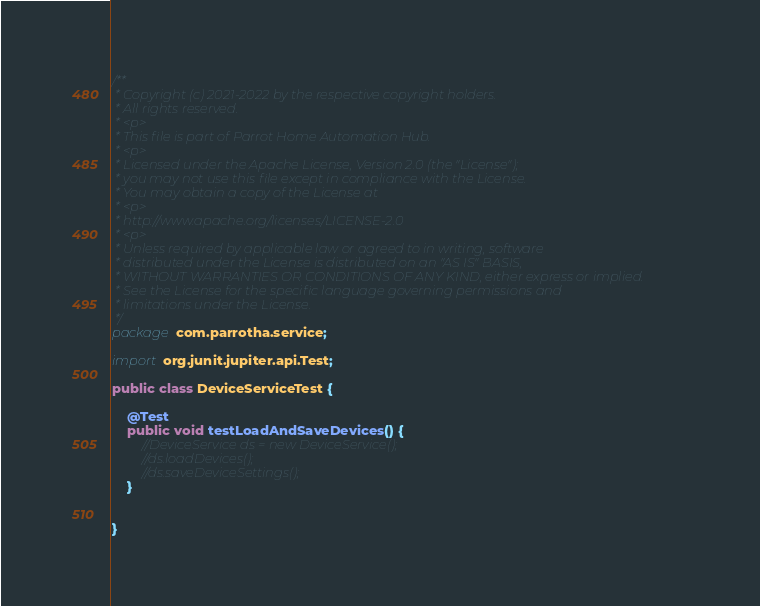Convert code to text. <code><loc_0><loc_0><loc_500><loc_500><_Java_>/**
 * Copyright (c) 2021-2022 by the respective copyright holders.
 * All rights reserved.
 * <p>
 * This file is part of Parrot Home Automation Hub.
 * <p>
 * Licensed under the Apache License, Version 2.0 (the "License");
 * you may not use this file except in compliance with the License.
 * You may obtain a copy of the License at
 * <p>
 * http://www.apache.org/licenses/LICENSE-2.0
 * <p>
 * Unless required by applicable law or agreed to in writing, software
 * distributed under the License is distributed on an "AS IS" BASIS,
 * WITHOUT WARRANTIES OR CONDITIONS OF ANY KIND, either express or implied.
 * See the License for the specific language governing permissions and
 * limitations under the License.
 */
package com.parrotha.service;

import org.junit.jupiter.api.Test;

public class DeviceServiceTest {

    @Test
    public void testLoadAndSaveDevices() {
        //DeviceService ds = new DeviceService();
        //ds.loadDevices();
        //ds.saveDeviceSettings();
    }


}
</code> 